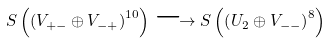Convert formula to latex. <formula><loc_0><loc_0><loc_500><loc_500>S \left ( \left ( V _ { + - } \oplus V _ { - + } \right ) ^ { 1 0 } \right ) \longrightarrow S \left ( \left ( U _ { 2 } \oplus V _ { - - } \right ) ^ { 8 } \right )</formula> 